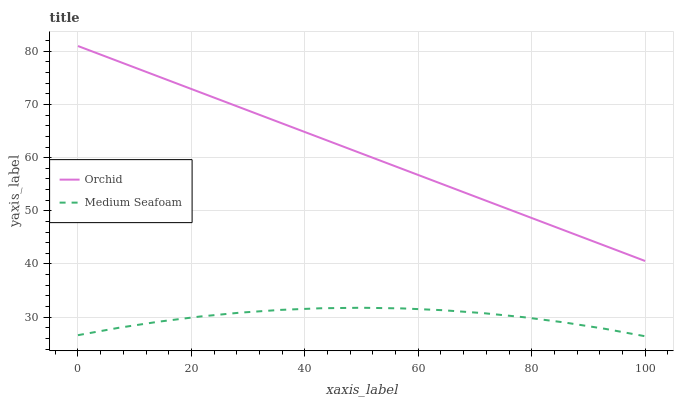Does Medium Seafoam have the minimum area under the curve?
Answer yes or no. Yes. Does Orchid have the maximum area under the curve?
Answer yes or no. Yes. Does Orchid have the minimum area under the curve?
Answer yes or no. No. Is Orchid the smoothest?
Answer yes or no. Yes. Is Medium Seafoam the roughest?
Answer yes or no. Yes. Is Orchid the roughest?
Answer yes or no. No. Does Orchid have the lowest value?
Answer yes or no. No. Does Orchid have the highest value?
Answer yes or no. Yes. Is Medium Seafoam less than Orchid?
Answer yes or no. Yes. Is Orchid greater than Medium Seafoam?
Answer yes or no. Yes. Does Medium Seafoam intersect Orchid?
Answer yes or no. No. 